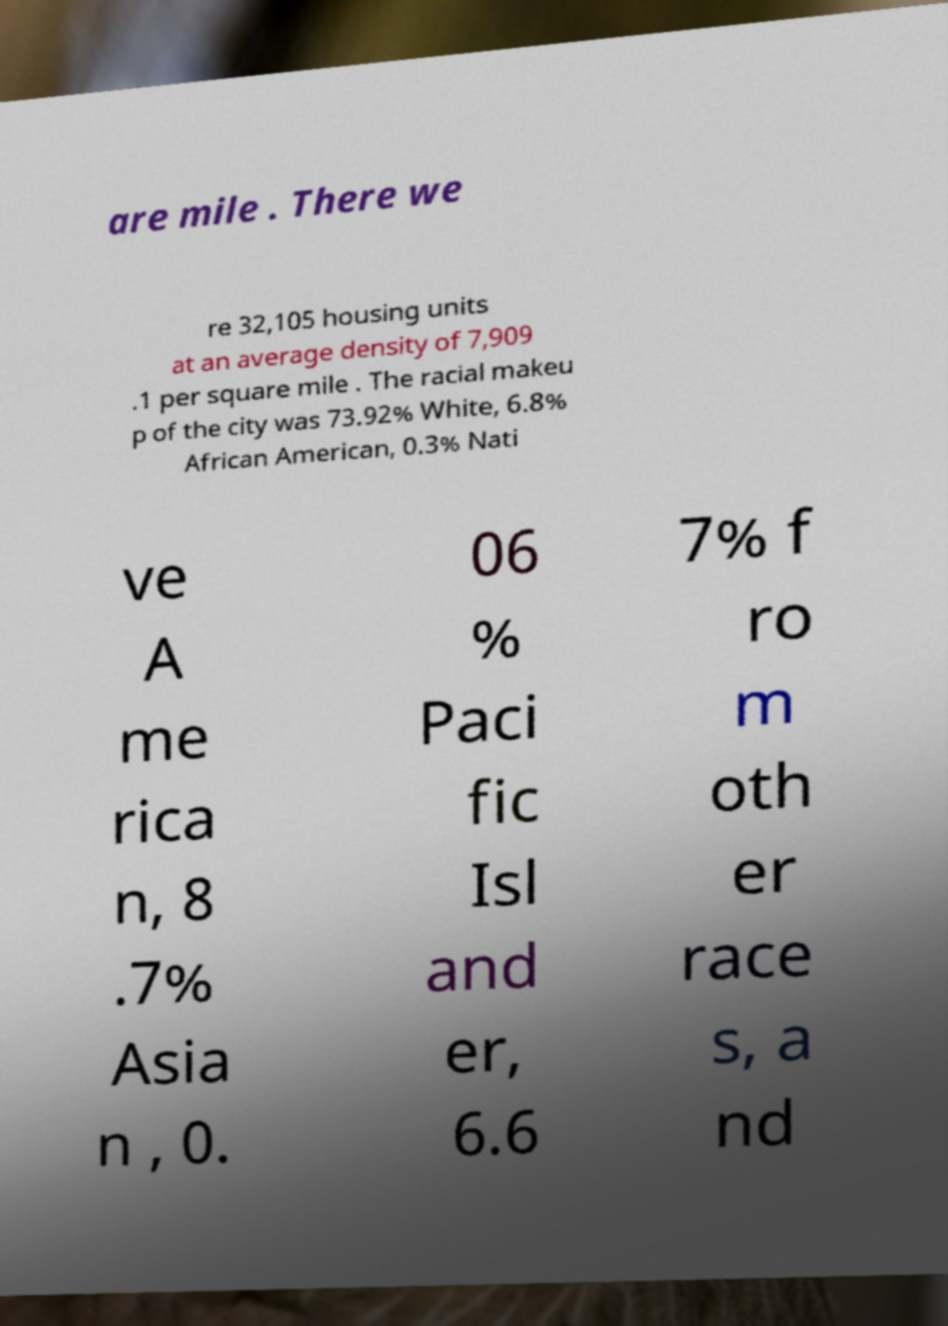Please read and relay the text visible in this image. What does it say? are mile . There we re 32,105 housing units at an average density of 7,909 .1 per square mile . The racial makeu p of the city was 73.92% White, 6.8% African American, 0.3% Nati ve A me rica n, 8 .7% Asia n , 0. 06 % Paci fic Isl and er, 6.6 7% f ro m oth er race s, a nd 